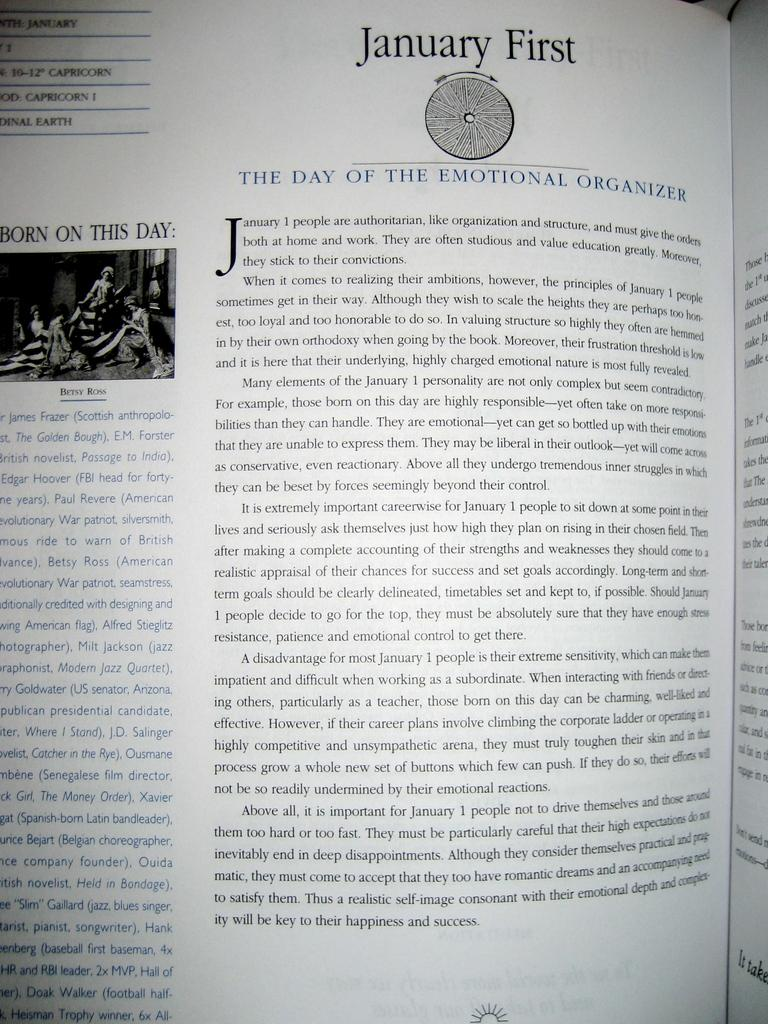<image>
Present a compact description of the photo's key features. A textbook open to a page titled January First. 